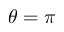<formula> <loc_0><loc_0><loc_500><loc_500>\theta = \pi</formula> 